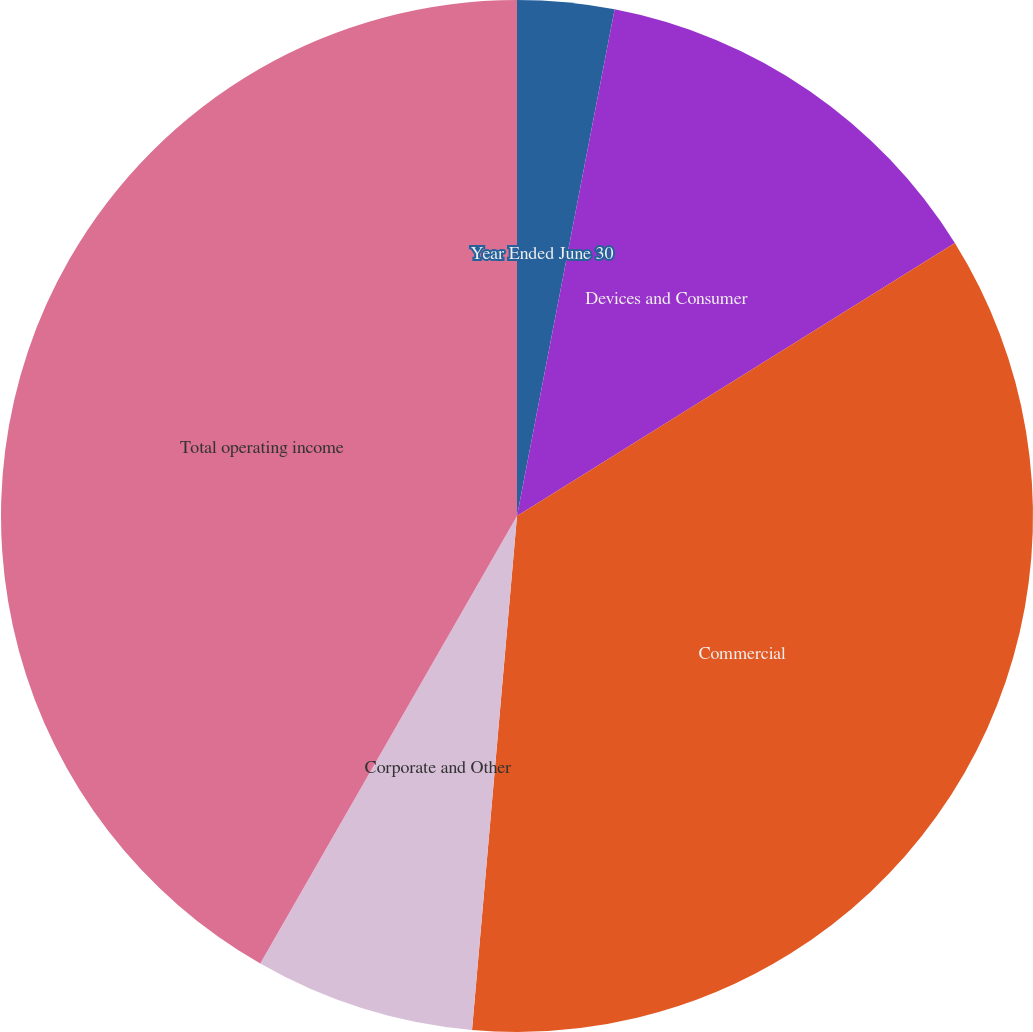Convert chart to OTSL. <chart><loc_0><loc_0><loc_500><loc_500><pie_chart><fcel>Year Ended June 30<fcel>Devices and Consumer<fcel>Commercial<fcel>Corporate and Other<fcel>Total operating income<nl><fcel>3.03%<fcel>13.1%<fcel>35.27%<fcel>6.9%<fcel>41.72%<nl></chart> 